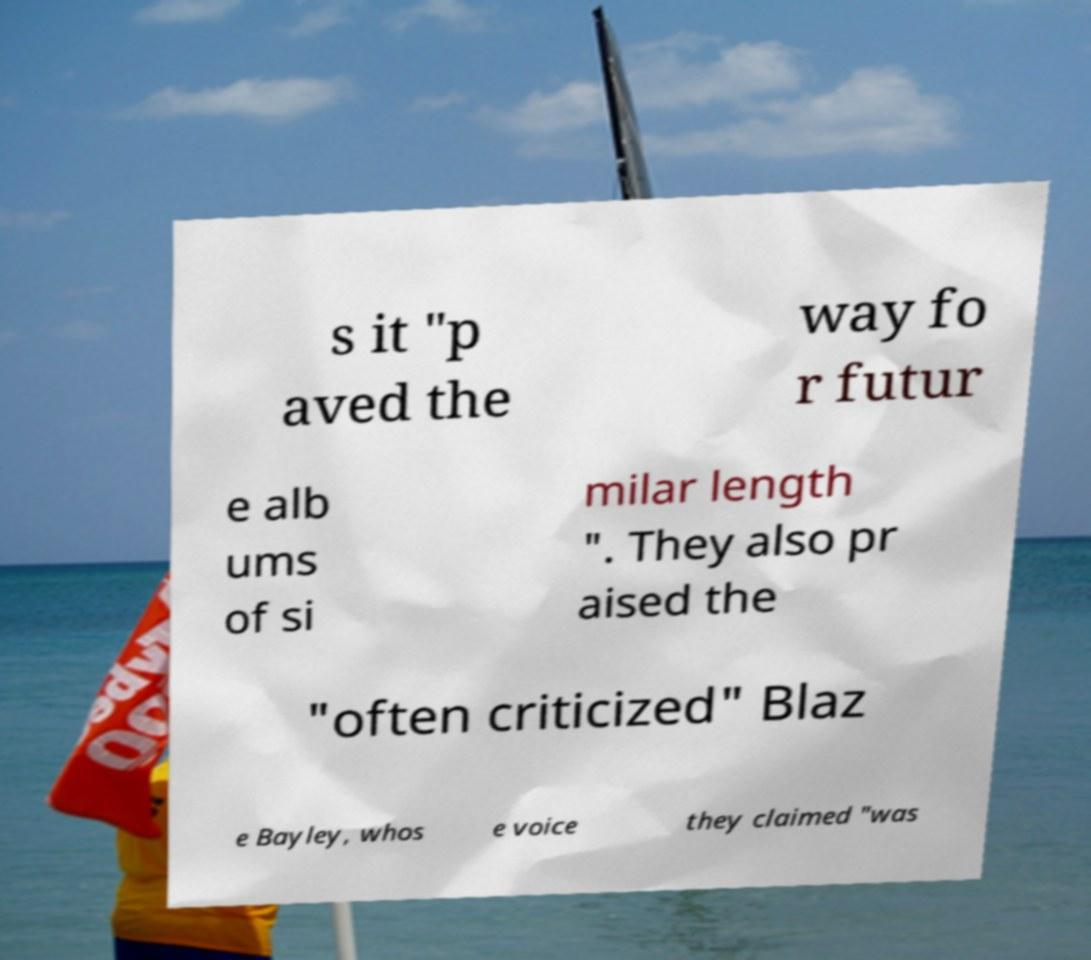For documentation purposes, I need the text within this image transcribed. Could you provide that? s it "p aved the way fo r futur e alb ums of si milar length ". They also pr aised the "often criticized" Blaz e Bayley, whos e voice they claimed "was 